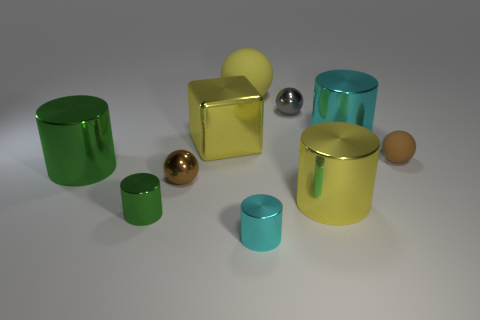Subtract all big yellow spheres. How many spheres are left? 3 Subtract 0 red balls. How many objects are left? 10 Subtract all balls. How many objects are left? 6 Subtract 1 balls. How many balls are left? 3 Subtract all blue balls. Subtract all gray blocks. How many balls are left? 4 Subtract all green cylinders. How many green spheres are left? 0 Subtract all brown objects. Subtract all small gray balls. How many objects are left? 7 Add 8 gray metal things. How many gray metal things are left? 9 Add 5 cubes. How many cubes exist? 6 Subtract all cyan cylinders. How many cylinders are left? 3 